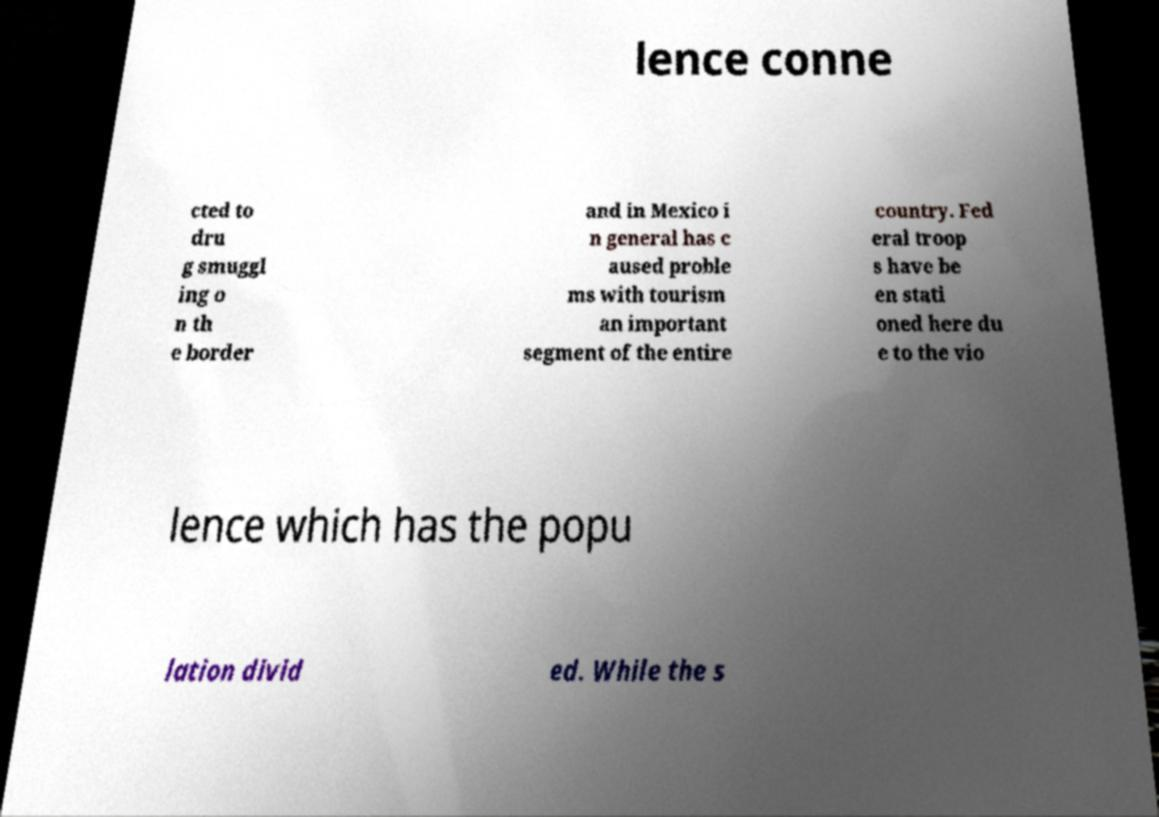For documentation purposes, I need the text within this image transcribed. Could you provide that? lence conne cted to dru g smuggl ing o n th e border and in Mexico i n general has c aused proble ms with tourism an important segment of the entire country. Fed eral troop s have be en stati oned here du e to the vio lence which has the popu lation divid ed. While the s 